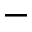<formula> <loc_0><loc_0><loc_500><loc_500>-</formula> 